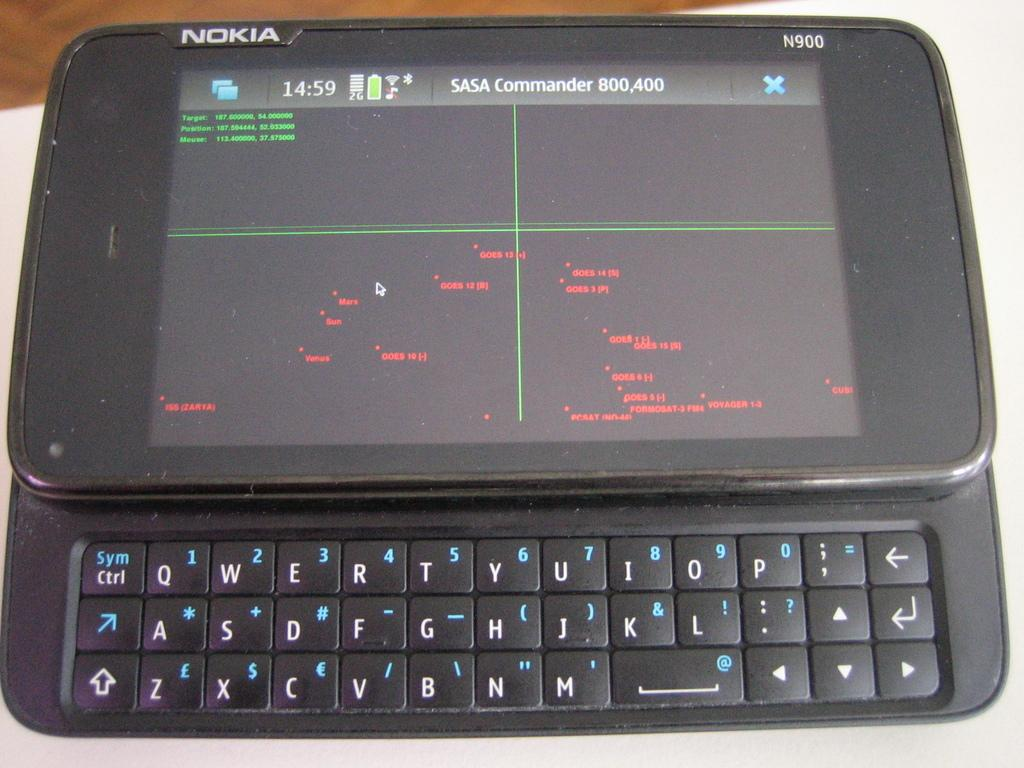<image>
Summarize the visual content of the image. A Nokia phone opened to the SASA Commander 800,400. 